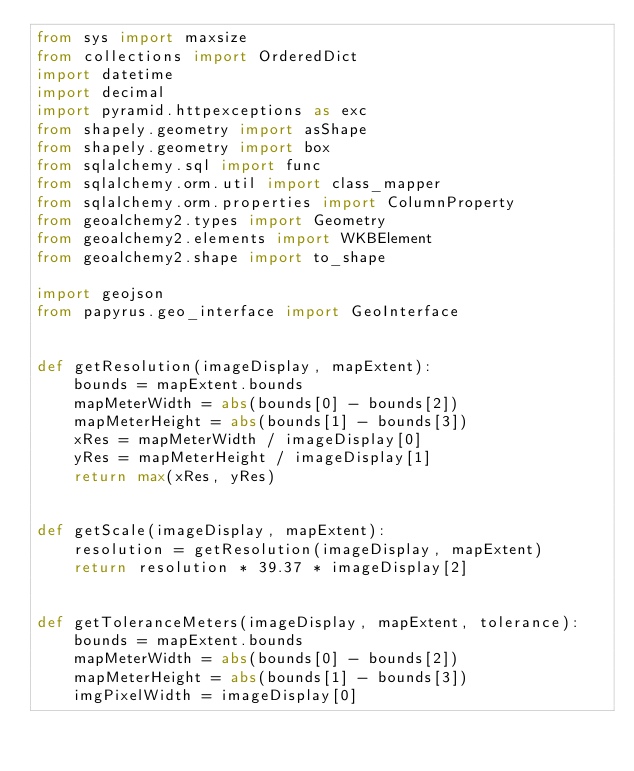Convert code to text. <code><loc_0><loc_0><loc_500><loc_500><_Python_>from sys import maxsize
from collections import OrderedDict
import datetime
import decimal
import pyramid.httpexceptions as exc
from shapely.geometry import asShape
from shapely.geometry import box
from sqlalchemy.sql import func
from sqlalchemy.orm.util import class_mapper
from sqlalchemy.orm.properties import ColumnProperty
from geoalchemy2.types import Geometry
from geoalchemy2.elements import WKBElement
from geoalchemy2.shape import to_shape

import geojson
from papyrus.geo_interface import GeoInterface


def getResolution(imageDisplay, mapExtent):
    bounds = mapExtent.bounds
    mapMeterWidth = abs(bounds[0] - bounds[2])
    mapMeterHeight = abs(bounds[1] - bounds[3])
    xRes = mapMeterWidth / imageDisplay[0]
    yRes = mapMeterHeight / imageDisplay[1]
    return max(xRes, yRes)


def getScale(imageDisplay, mapExtent):
    resolution = getResolution(imageDisplay, mapExtent)
    return resolution * 39.37 * imageDisplay[2]


def getToleranceMeters(imageDisplay, mapExtent, tolerance):
    bounds = mapExtent.bounds
    mapMeterWidth = abs(bounds[0] - bounds[2])
    mapMeterHeight = abs(bounds[1] - bounds[3])
    imgPixelWidth = imageDisplay[0]</code> 